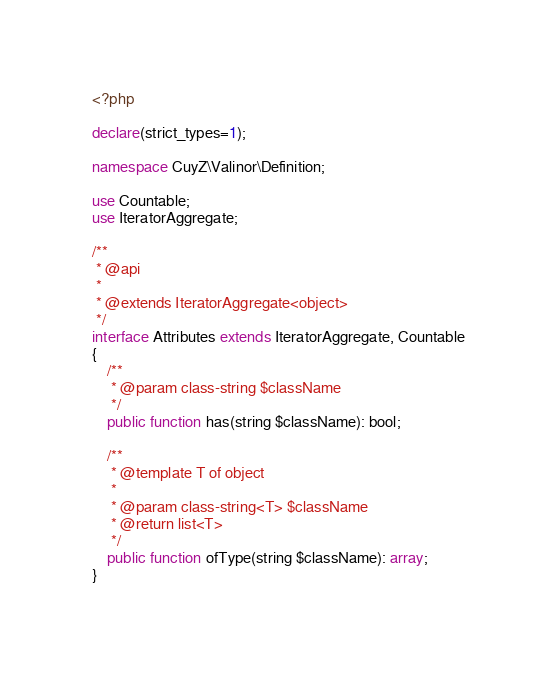Convert code to text. <code><loc_0><loc_0><loc_500><loc_500><_PHP_><?php

declare(strict_types=1);

namespace CuyZ\Valinor\Definition;

use Countable;
use IteratorAggregate;

/**
 * @api
 *
 * @extends IteratorAggregate<object>
 */
interface Attributes extends IteratorAggregate, Countable
{
    /**
     * @param class-string $className
     */
    public function has(string $className): bool;

    /**
     * @template T of object
     *
     * @param class-string<T> $className
     * @return list<T>
     */
    public function ofType(string $className): array;
}
</code> 